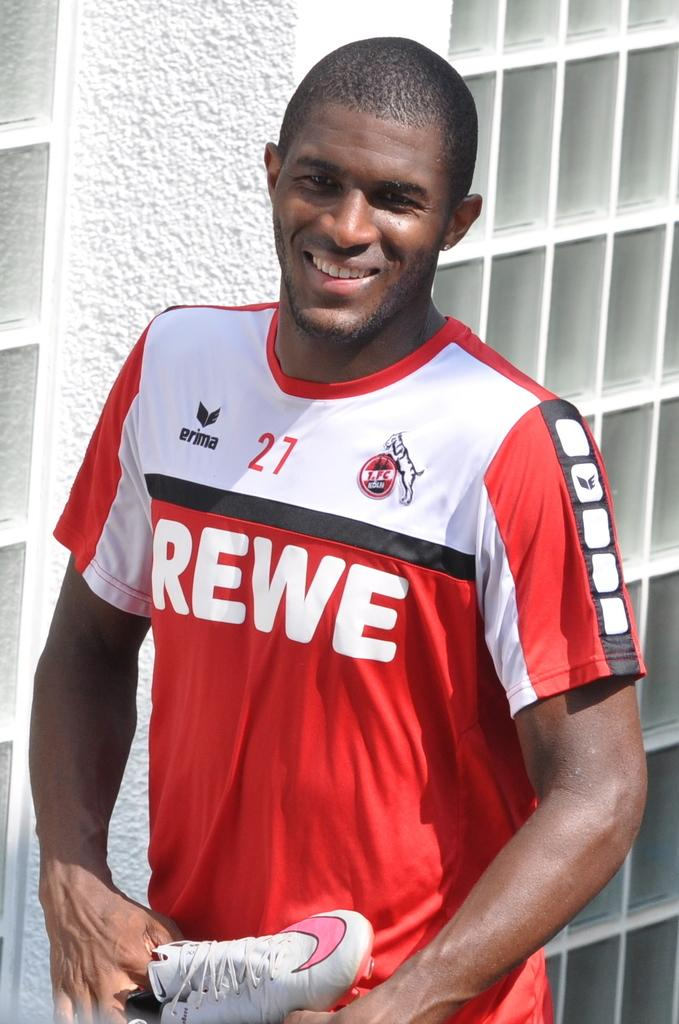Provide a one-sentence caption for the provided image. Man with a rewe jersey standing and posing for a picture. 